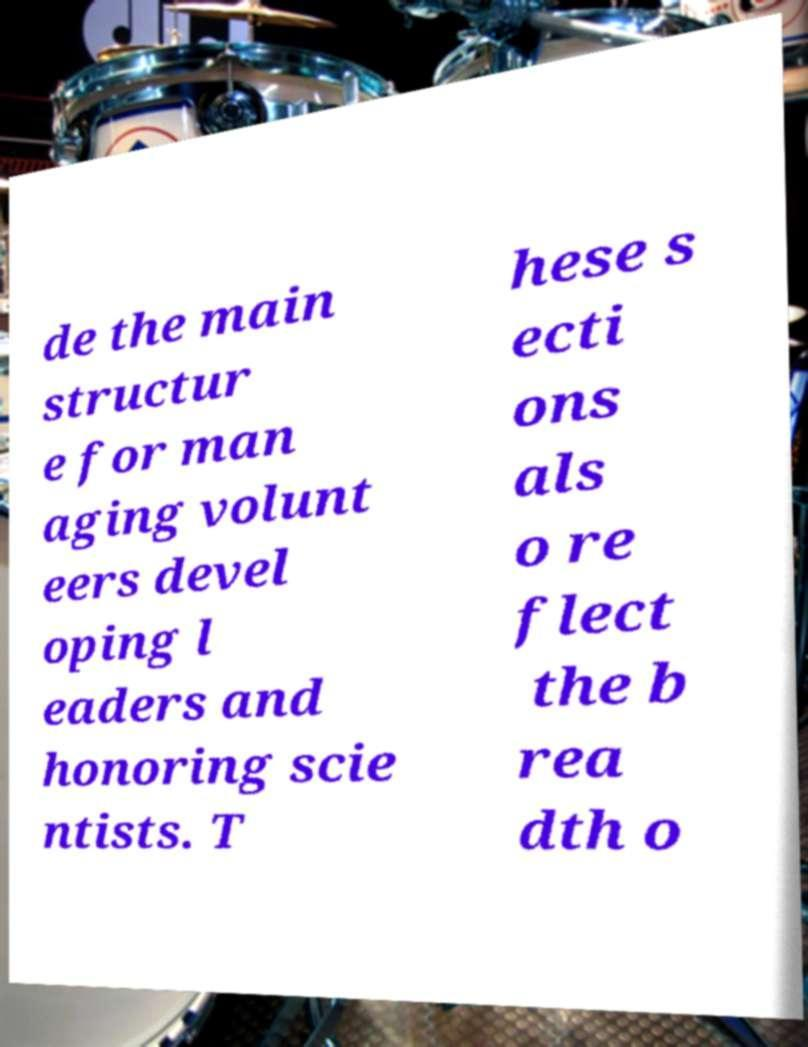Can you read and provide the text displayed in the image?This photo seems to have some interesting text. Can you extract and type it out for me? de the main structur e for man aging volunt eers devel oping l eaders and honoring scie ntists. T hese s ecti ons als o re flect the b rea dth o 